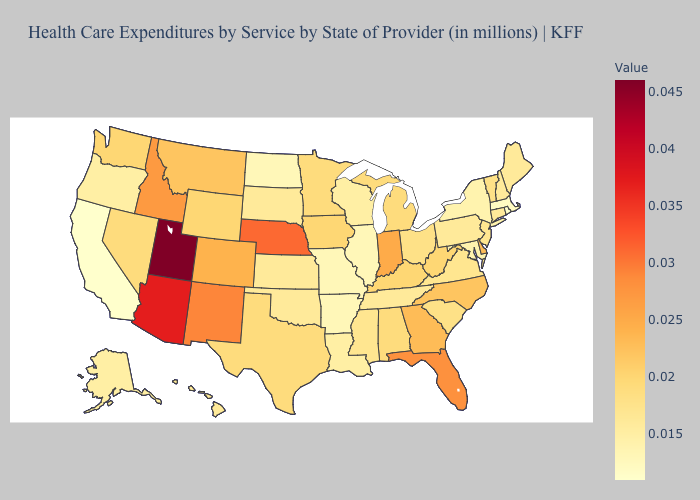Does Indiana have a higher value than Utah?
Quick response, please. No. Which states have the lowest value in the USA?
Be succinct. California, Rhode Island. Does Arkansas have the lowest value in the South?
Write a very short answer. Yes. Among the states that border Rhode Island , does Massachusetts have the lowest value?
Give a very brief answer. Yes. Is the legend a continuous bar?
Write a very short answer. Yes. Among the states that border Virginia , does Tennessee have the lowest value?
Concise answer only. No. Among the states that border Virginia , does Maryland have the lowest value?
Give a very brief answer. Yes. 